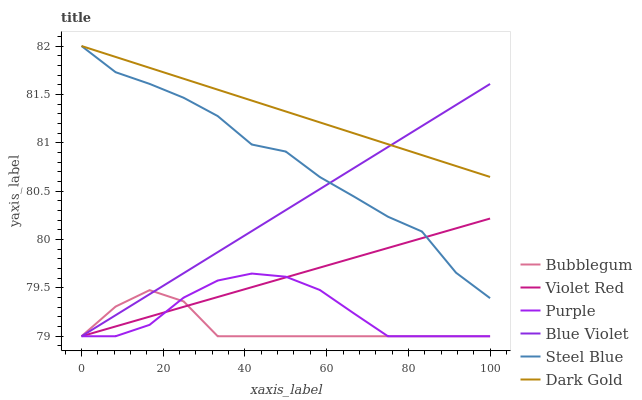Does Bubblegum have the minimum area under the curve?
Answer yes or no. Yes. Does Dark Gold have the maximum area under the curve?
Answer yes or no. Yes. Does Purple have the minimum area under the curve?
Answer yes or no. No. Does Purple have the maximum area under the curve?
Answer yes or no. No. Is Blue Violet the smoothest?
Answer yes or no. Yes. Is Steel Blue the roughest?
Answer yes or no. Yes. Is Dark Gold the smoothest?
Answer yes or no. No. Is Dark Gold the roughest?
Answer yes or no. No. Does Violet Red have the lowest value?
Answer yes or no. Yes. Does Dark Gold have the lowest value?
Answer yes or no. No. Does Steel Blue have the highest value?
Answer yes or no. Yes. Does Purple have the highest value?
Answer yes or no. No. Is Purple less than Dark Gold?
Answer yes or no. Yes. Is Steel Blue greater than Bubblegum?
Answer yes or no. Yes. Does Dark Gold intersect Blue Violet?
Answer yes or no. Yes. Is Dark Gold less than Blue Violet?
Answer yes or no. No. Is Dark Gold greater than Blue Violet?
Answer yes or no. No. Does Purple intersect Dark Gold?
Answer yes or no. No. 